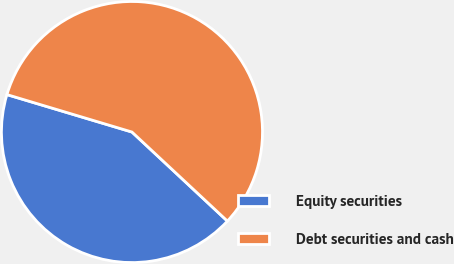<chart> <loc_0><loc_0><loc_500><loc_500><pie_chart><fcel>Equity securities<fcel>Debt securities and cash<nl><fcel>42.68%<fcel>57.32%<nl></chart> 